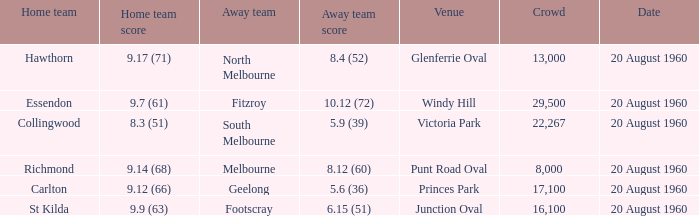What is the crowd size of the game when Fitzroy is the away team? 1.0. Can you give me this table as a dict? {'header': ['Home team', 'Home team score', 'Away team', 'Away team score', 'Venue', 'Crowd', 'Date'], 'rows': [['Hawthorn', '9.17 (71)', 'North Melbourne', '8.4 (52)', 'Glenferrie Oval', '13,000', '20 August 1960'], ['Essendon', '9.7 (61)', 'Fitzroy', '10.12 (72)', 'Windy Hill', '29,500', '20 August 1960'], ['Collingwood', '8.3 (51)', 'South Melbourne', '5.9 (39)', 'Victoria Park', '22,267', '20 August 1960'], ['Richmond', '9.14 (68)', 'Melbourne', '8.12 (60)', 'Punt Road Oval', '8,000', '20 August 1960'], ['Carlton', '9.12 (66)', 'Geelong', '5.6 (36)', 'Princes Park', '17,100', '20 August 1960'], ['St Kilda', '9.9 (63)', 'Footscray', '6.15 (51)', 'Junction Oval', '16,100', '20 August 1960']]} 